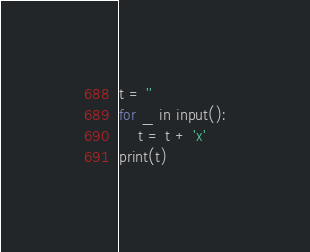Convert code to text. <code><loc_0><loc_0><loc_500><loc_500><_Python_>t = ''
for _ in input():
    t = t + 'x'
print(t)</code> 